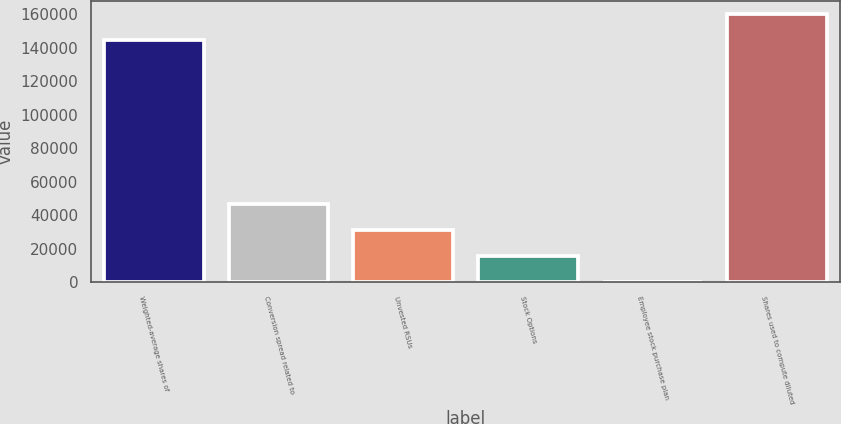Convert chart. <chart><loc_0><loc_0><loc_500><loc_500><bar_chart><fcel>Weighted-average shares of<fcel>Conversion spread related to<fcel>Unvested RSUs<fcel>Stock Options<fcel>Employee stock purchase plan<fcel>Shares used to compute diluted<nl><fcel>144591<fcel>46758.9<fcel>31183.6<fcel>15608.3<fcel>33<fcel>160166<nl></chart> 